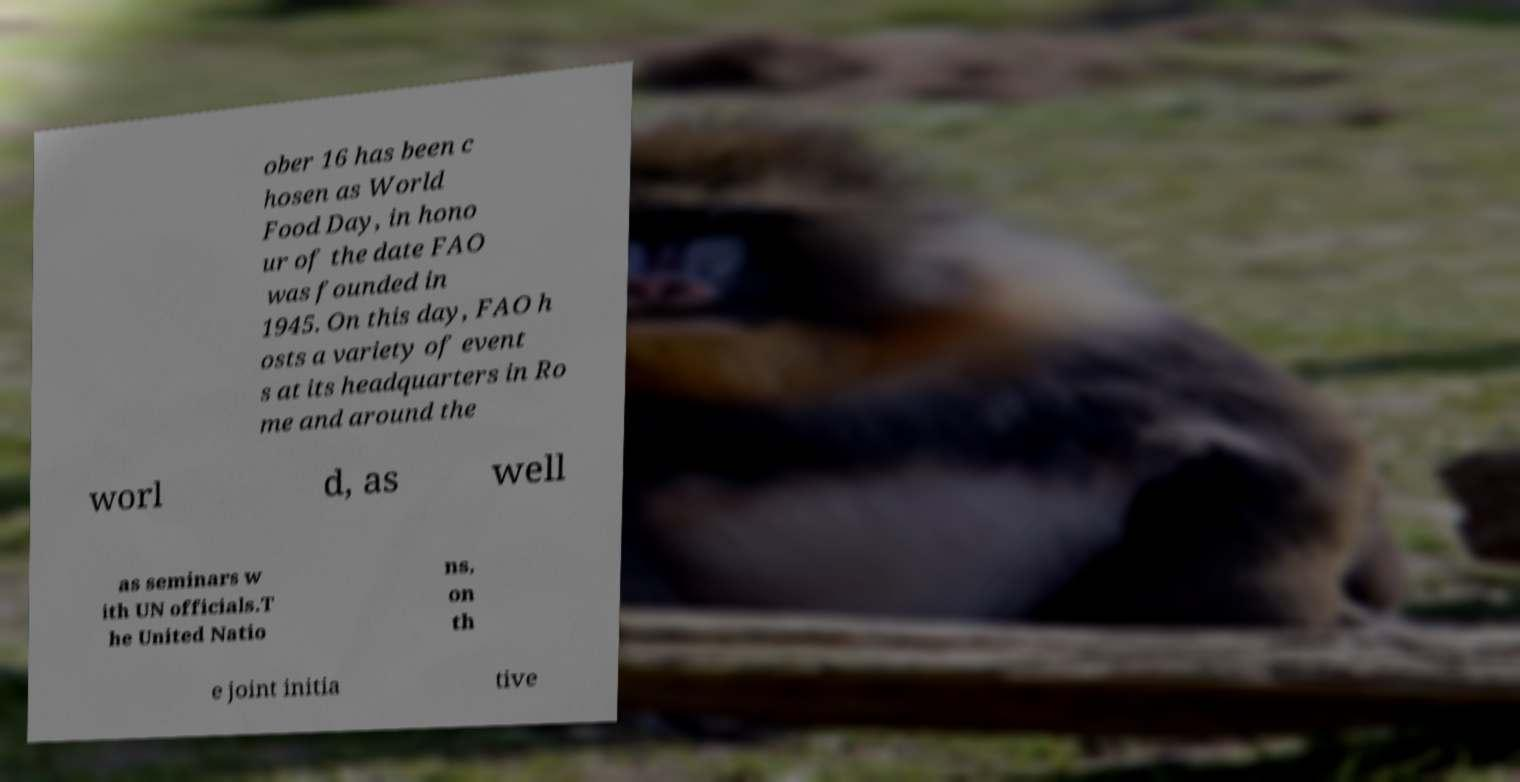Please read and relay the text visible in this image. What does it say? ober 16 has been c hosen as World Food Day, in hono ur of the date FAO was founded in 1945. On this day, FAO h osts a variety of event s at its headquarters in Ro me and around the worl d, as well as seminars w ith UN officials.T he United Natio ns, on th e joint initia tive 